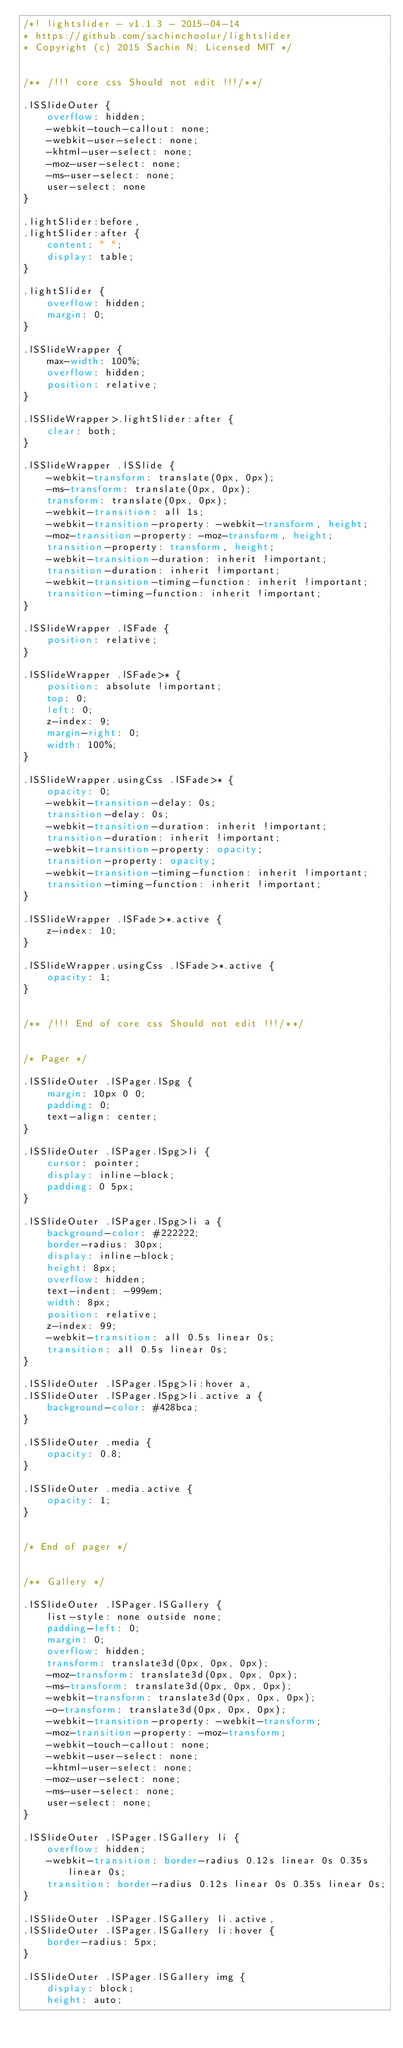<code> <loc_0><loc_0><loc_500><loc_500><_CSS_>/*! lightslider - v1.1.3 - 2015-04-14
* https://github.com/sachinchoolur/lightslider
* Copyright (c) 2015 Sachin N; Licensed MIT */


/** /!!! core css Should not edit !!!/**/

.lSSlideOuter {
    overflow: hidden;
    -webkit-touch-callout: none;
    -webkit-user-select: none;
    -khtml-user-select: none;
    -moz-user-select: none;
    -ms-user-select: none;
    user-select: none
}

.lightSlider:before,
.lightSlider:after {
    content: " ";
    display: table;
}

.lightSlider {
    overflow: hidden;
    margin: 0;
}

.lSSlideWrapper {
    max-width: 100%;
    overflow: hidden;
    position: relative;
}

.lSSlideWrapper>.lightSlider:after {
    clear: both;
}

.lSSlideWrapper .lSSlide {
    -webkit-transform: translate(0px, 0px);
    -ms-transform: translate(0px, 0px);
    transform: translate(0px, 0px);
    -webkit-transition: all 1s;
    -webkit-transition-property: -webkit-transform, height;
    -moz-transition-property: -moz-transform, height;
    transition-property: transform, height;
    -webkit-transition-duration: inherit !important;
    transition-duration: inherit !important;
    -webkit-transition-timing-function: inherit !important;
    transition-timing-function: inherit !important;
}

.lSSlideWrapper .lSFade {
    position: relative;
}

.lSSlideWrapper .lSFade>* {
    position: absolute !important;
    top: 0;
    left: 0;
    z-index: 9;
    margin-right: 0;
    width: 100%;
}

.lSSlideWrapper.usingCss .lSFade>* {
    opacity: 0;
    -webkit-transition-delay: 0s;
    transition-delay: 0s;
    -webkit-transition-duration: inherit !important;
    transition-duration: inherit !important;
    -webkit-transition-property: opacity;
    transition-property: opacity;
    -webkit-transition-timing-function: inherit !important;
    transition-timing-function: inherit !important;
}

.lSSlideWrapper .lSFade>*.active {
    z-index: 10;
}

.lSSlideWrapper.usingCss .lSFade>*.active {
    opacity: 1;
}


/** /!!! End of core css Should not edit !!!/**/


/* Pager */

.lSSlideOuter .lSPager.lSpg {
    margin: 10px 0 0;
    padding: 0;
    text-align: center;
}

.lSSlideOuter .lSPager.lSpg>li {
    cursor: pointer;
    display: inline-block;
    padding: 0 5px;
}

.lSSlideOuter .lSPager.lSpg>li a {
    background-color: #222222;
    border-radius: 30px;
    display: inline-block;
    height: 8px;
    overflow: hidden;
    text-indent: -999em;
    width: 8px;
    position: relative;
    z-index: 99;
    -webkit-transition: all 0.5s linear 0s;
    transition: all 0.5s linear 0s;
}

.lSSlideOuter .lSPager.lSpg>li:hover a,
.lSSlideOuter .lSPager.lSpg>li.active a {
    background-color: #428bca;
}

.lSSlideOuter .media {
    opacity: 0.8;
}

.lSSlideOuter .media.active {
    opacity: 1;
}


/* End of pager */


/** Gallery */

.lSSlideOuter .lSPager.lSGallery {
    list-style: none outside none;
    padding-left: 0;
    margin: 0;
    overflow: hidden;
    transform: translate3d(0px, 0px, 0px);
    -moz-transform: translate3d(0px, 0px, 0px);
    -ms-transform: translate3d(0px, 0px, 0px);
    -webkit-transform: translate3d(0px, 0px, 0px);
    -o-transform: translate3d(0px, 0px, 0px);
    -webkit-transition-property: -webkit-transform;
    -moz-transition-property: -moz-transform;
    -webkit-touch-callout: none;
    -webkit-user-select: none;
    -khtml-user-select: none;
    -moz-user-select: none;
    -ms-user-select: none;
    user-select: none;
}

.lSSlideOuter .lSPager.lSGallery li {
    overflow: hidden;
    -webkit-transition: border-radius 0.12s linear 0s 0.35s linear 0s;
    transition: border-radius 0.12s linear 0s 0.35s linear 0s;
}

.lSSlideOuter .lSPager.lSGallery li.active,
.lSSlideOuter .lSPager.lSGallery li:hover {
    border-radius: 5px;
}

.lSSlideOuter .lSPager.lSGallery img {
    display: block;
    height: auto;</code> 